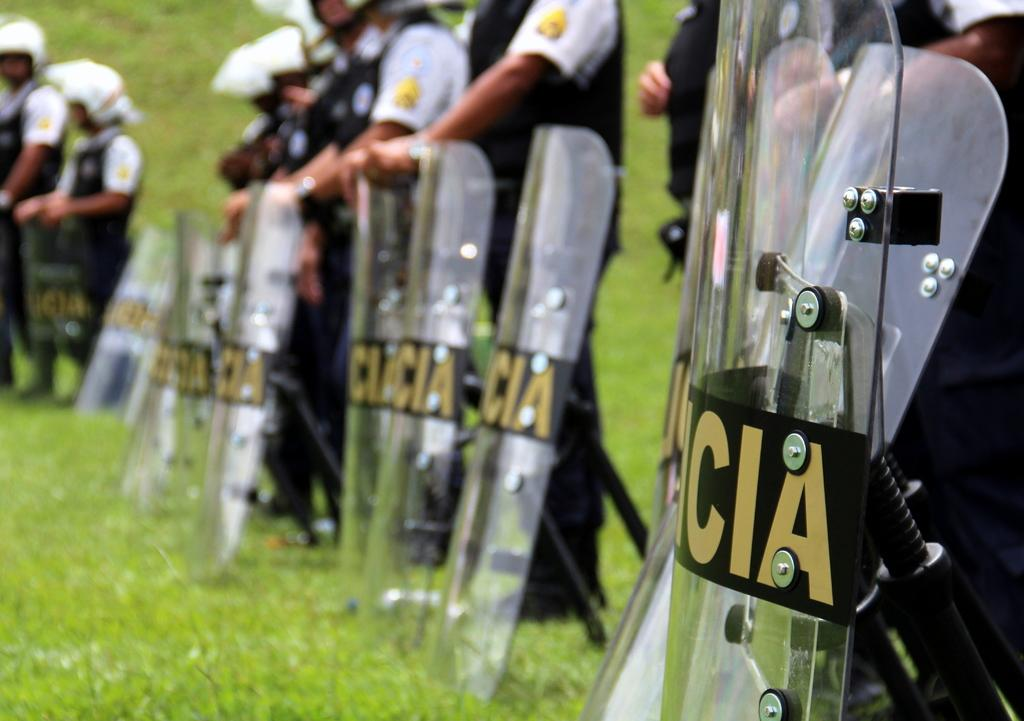What type of people can be seen in the image? There are soldiers in the image. What are the soldiers holding in their hands? The soldiers are holding shields. What type of terrain is visible in the image? There is grass visible in the image. Where is the jail located in the image? There is no jail present in the image. What type of machine can be seen in the image? There is no machine present in the image. 